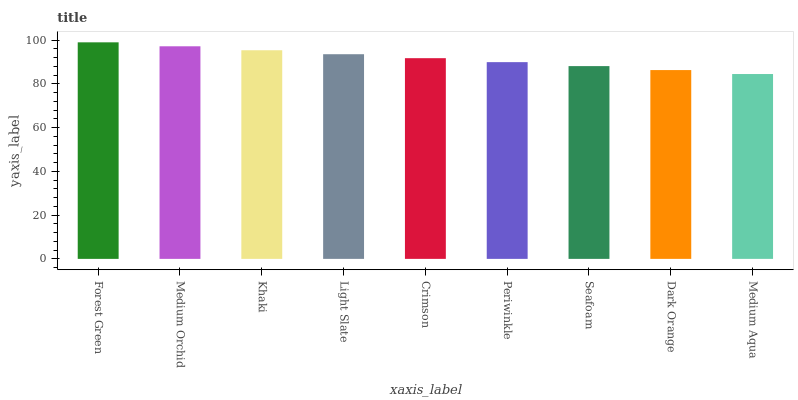Is Medium Aqua the minimum?
Answer yes or no. Yes. Is Forest Green the maximum?
Answer yes or no. Yes. Is Medium Orchid the minimum?
Answer yes or no. No. Is Medium Orchid the maximum?
Answer yes or no. No. Is Forest Green greater than Medium Orchid?
Answer yes or no. Yes. Is Medium Orchid less than Forest Green?
Answer yes or no. Yes. Is Medium Orchid greater than Forest Green?
Answer yes or no. No. Is Forest Green less than Medium Orchid?
Answer yes or no. No. Is Crimson the high median?
Answer yes or no. Yes. Is Crimson the low median?
Answer yes or no. Yes. Is Medium Aqua the high median?
Answer yes or no. No. Is Light Slate the low median?
Answer yes or no. No. 